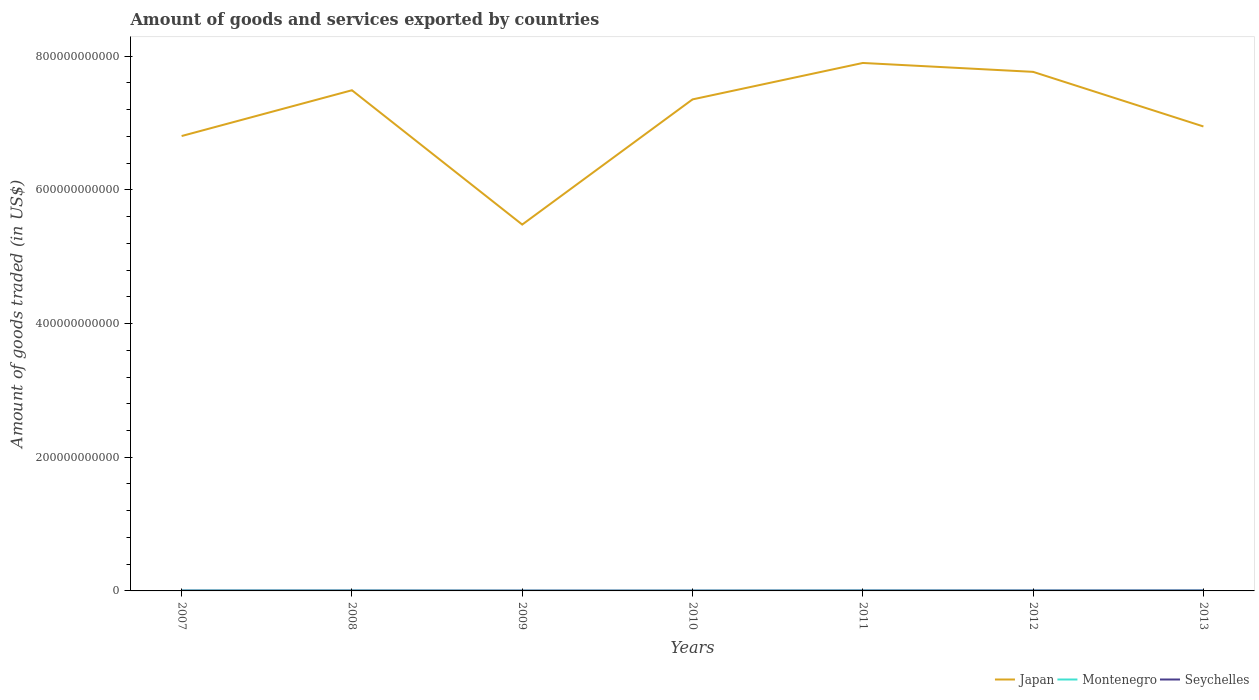Does the line corresponding to Montenegro intersect with the line corresponding to Seychelles?
Provide a succinct answer. Yes. Across all years, what is the maximum total amount of goods and services exported in Seychelles?
Keep it short and to the point. 3.98e+08. What is the total total amount of goods and services exported in Japan in the graph?
Ensure brevity in your answer.  -1.87e+11. What is the difference between the highest and the second highest total amount of goods and services exported in Seychelles?
Offer a terse response. 2.32e+08. How many years are there in the graph?
Keep it short and to the point. 7. What is the difference between two consecutive major ticks on the Y-axis?
Ensure brevity in your answer.  2.00e+11. Does the graph contain any zero values?
Ensure brevity in your answer.  No. How many legend labels are there?
Your response must be concise. 3. How are the legend labels stacked?
Provide a short and direct response. Horizontal. What is the title of the graph?
Your answer should be very brief. Amount of goods and services exported by countries. Does "Arab World" appear as one of the legend labels in the graph?
Offer a terse response. No. What is the label or title of the X-axis?
Make the answer very short. Years. What is the label or title of the Y-axis?
Give a very brief answer. Amount of goods traded (in US$). What is the Amount of goods traded (in US$) in Japan in 2007?
Offer a very short reply. 6.81e+11. What is the Amount of goods traded (in US$) in Montenegro in 2007?
Offer a very short reply. 6.48e+08. What is the Amount of goods traded (in US$) in Seychelles in 2007?
Your response must be concise. 3.98e+08. What is the Amount of goods traded (in US$) of Japan in 2008?
Offer a terse response. 7.49e+11. What is the Amount of goods traded (in US$) of Montenegro in 2008?
Your response must be concise. 6.23e+08. What is the Amount of goods traded (in US$) in Seychelles in 2008?
Make the answer very short. 4.38e+08. What is the Amount of goods traded (in US$) in Japan in 2009?
Your answer should be compact. 5.48e+11. What is the Amount of goods traded (in US$) of Montenegro in 2009?
Give a very brief answer. 3.83e+08. What is the Amount of goods traded (in US$) of Seychelles in 2009?
Offer a terse response. 4.32e+08. What is the Amount of goods traded (in US$) of Japan in 2010?
Ensure brevity in your answer.  7.35e+11. What is the Amount of goods traded (in US$) of Montenegro in 2010?
Your answer should be very brief. 4.49e+08. What is the Amount of goods traded (in US$) in Seychelles in 2010?
Offer a terse response. 4.00e+08. What is the Amount of goods traded (in US$) in Japan in 2011?
Offer a very short reply. 7.90e+11. What is the Amount of goods traded (in US$) in Montenegro in 2011?
Keep it short and to the point. 6.54e+08. What is the Amount of goods traded (in US$) of Seychelles in 2011?
Ensure brevity in your answer.  4.77e+08. What is the Amount of goods traded (in US$) of Japan in 2012?
Your answer should be very brief. 7.77e+11. What is the Amount of goods traded (in US$) in Montenegro in 2012?
Ensure brevity in your answer.  4.99e+08. What is the Amount of goods traded (in US$) in Seychelles in 2012?
Your answer should be compact. 5.59e+08. What is the Amount of goods traded (in US$) of Japan in 2013?
Offer a very short reply. 6.95e+11. What is the Amount of goods traded (in US$) of Montenegro in 2013?
Your response must be concise. 5.25e+08. What is the Amount of goods traded (in US$) in Seychelles in 2013?
Make the answer very short. 6.29e+08. Across all years, what is the maximum Amount of goods traded (in US$) in Japan?
Make the answer very short. 7.90e+11. Across all years, what is the maximum Amount of goods traded (in US$) in Montenegro?
Provide a succinct answer. 6.54e+08. Across all years, what is the maximum Amount of goods traded (in US$) of Seychelles?
Offer a very short reply. 6.29e+08. Across all years, what is the minimum Amount of goods traded (in US$) in Japan?
Offer a terse response. 5.48e+11. Across all years, what is the minimum Amount of goods traded (in US$) of Montenegro?
Provide a succinct answer. 3.83e+08. Across all years, what is the minimum Amount of goods traded (in US$) of Seychelles?
Give a very brief answer. 3.98e+08. What is the total Amount of goods traded (in US$) of Japan in the graph?
Your answer should be compact. 4.97e+12. What is the total Amount of goods traded (in US$) in Montenegro in the graph?
Your response must be concise. 3.78e+09. What is the total Amount of goods traded (in US$) of Seychelles in the graph?
Offer a terse response. 3.33e+09. What is the difference between the Amount of goods traded (in US$) in Japan in 2007 and that in 2008?
Provide a short and direct response. -6.85e+1. What is the difference between the Amount of goods traded (in US$) of Montenegro in 2007 and that in 2008?
Your answer should be compact. 2.54e+07. What is the difference between the Amount of goods traded (in US$) in Seychelles in 2007 and that in 2008?
Your answer should be very brief. -4.01e+07. What is the difference between the Amount of goods traded (in US$) in Japan in 2007 and that in 2009?
Your answer should be very brief. 1.32e+11. What is the difference between the Amount of goods traded (in US$) in Montenegro in 2007 and that in 2009?
Make the answer very short. 2.65e+08. What is the difference between the Amount of goods traded (in US$) in Seychelles in 2007 and that in 2009?
Make the answer very short. -3.42e+07. What is the difference between the Amount of goods traded (in US$) of Japan in 2007 and that in 2010?
Keep it short and to the point. -5.48e+1. What is the difference between the Amount of goods traded (in US$) in Montenegro in 2007 and that in 2010?
Make the answer very short. 1.99e+08. What is the difference between the Amount of goods traded (in US$) of Seychelles in 2007 and that in 2010?
Give a very brief answer. -2.68e+06. What is the difference between the Amount of goods traded (in US$) of Japan in 2007 and that in 2011?
Your answer should be very brief. -1.09e+11. What is the difference between the Amount of goods traded (in US$) of Montenegro in 2007 and that in 2011?
Provide a succinct answer. -5.49e+06. What is the difference between the Amount of goods traded (in US$) of Seychelles in 2007 and that in 2011?
Ensure brevity in your answer.  -7.93e+07. What is the difference between the Amount of goods traded (in US$) of Japan in 2007 and that in 2012?
Provide a succinct answer. -9.60e+1. What is the difference between the Amount of goods traded (in US$) in Montenegro in 2007 and that in 2012?
Offer a very short reply. 1.50e+08. What is the difference between the Amount of goods traded (in US$) of Seychelles in 2007 and that in 2012?
Your answer should be very brief. -1.62e+08. What is the difference between the Amount of goods traded (in US$) in Japan in 2007 and that in 2013?
Offer a terse response. -1.43e+1. What is the difference between the Amount of goods traded (in US$) in Montenegro in 2007 and that in 2013?
Give a very brief answer. 1.23e+08. What is the difference between the Amount of goods traded (in US$) of Seychelles in 2007 and that in 2013?
Give a very brief answer. -2.32e+08. What is the difference between the Amount of goods traded (in US$) in Japan in 2008 and that in 2009?
Offer a terse response. 2.01e+11. What is the difference between the Amount of goods traded (in US$) in Montenegro in 2008 and that in 2009?
Ensure brevity in your answer.  2.40e+08. What is the difference between the Amount of goods traded (in US$) in Seychelles in 2008 and that in 2009?
Make the answer very short. 5.81e+06. What is the difference between the Amount of goods traded (in US$) in Japan in 2008 and that in 2010?
Keep it short and to the point. 1.37e+1. What is the difference between the Amount of goods traded (in US$) in Montenegro in 2008 and that in 2010?
Offer a very short reply. 1.74e+08. What is the difference between the Amount of goods traded (in US$) in Seychelles in 2008 and that in 2010?
Provide a short and direct response. 3.74e+07. What is the difference between the Amount of goods traded (in US$) in Japan in 2008 and that in 2011?
Provide a succinct answer. -4.08e+1. What is the difference between the Amount of goods traded (in US$) of Montenegro in 2008 and that in 2011?
Your response must be concise. -3.09e+07. What is the difference between the Amount of goods traded (in US$) of Seychelles in 2008 and that in 2011?
Your answer should be compact. -3.93e+07. What is the difference between the Amount of goods traded (in US$) of Japan in 2008 and that in 2012?
Your answer should be compact. -2.75e+1. What is the difference between the Amount of goods traded (in US$) of Montenegro in 2008 and that in 2012?
Keep it short and to the point. 1.24e+08. What is the difference between the Amount of goods traded (in US$) in Seychelles in 2008 and that in 2012?
Your answer should be compact. -1.22e+08. What is the difference between the Amount of goods traded (in US$) in Japan in 2008 and that in 2013?
Make the answer very short. 5.42e+1. What is the difference between the Amount of goods traded (in US$) in Montenegro in 2008 and that in 2013?
Keep it short and to the point. 9.78e+07. What is the difference between the Amount of goods traded (in US$) of Seychelles in 2008 and that in 2013?
Your answer should be compact. -1.92e+08. What is the difference between the Amount of goods traded (in US$) of Japan in 2009 and that in 2010?
Your answer should be compact. -1.87e+11. What is the difference between the Amount of goods traded (in US$) in Montenegro in 2009 and that in 2010?
Give a very brief answer. -6.56e+07. What is the difference between the Amount of goods traded (in US$) in Seychelles in 2009 and that in 2010?
Your response must be concise. 3.16e+07. What is the difference between the Amount of goods traded (in US$) of Japan in 2009 and that in 2011?
Ensure brevity in your answer.  -2.42e+11. What is the difference between the Amount of goods traded (in US$) in Montenegro in 2009 and that in 2011?
Provide a short and direct response. -2.70e+08. What is the difference between the Amount of goods traded (in US$) in Seychelles in 2009 and that in 2011?
Offer a terse response. -4.51e+07. What is the difference between the Amount of goods traded (in US$) in Japan in 2009 and that in 2012?
Provide a short and direct response. -2.28e+11. What is the difference between the Amount of goods traded (in US$) of Montenegro in 2009 and that in 2012?
Offer a very short reply. -1.15e+08. What is the difference between the Amount of goods traded (in US$) of Seychelles in 2009 and that in 2012?
Provide a short and direct response. -1.27e+08. What is the difference between the Amount of goods traded (in US$) in Japan in 2009 and that in 2013?
Offer a very short reply. -1.47e+11. What is the difference between the Amount of goods traded (in US$) of Montenegro in 2009 and that in 2013?
Offer a very short reply. -1.42e+08. What is the difference between the Amount of goods traded (in US$) of Seychelles in 2009 and that in 2013?
Provide a short and direct response. -1.97e+08. What is the difference between the Amount of goods traded (in US$) in Japan in 2010 and that in 2011?
Offer a very short reply. -5.45e+1. What is the difference between the Amount of goods traded (in US$) in Montenegro in 2010 and that in 2011?
Offer a very short reply. -2.05e+08. What is the difference between the Amount of goods traded (in US$) in Seychelles in 2010 and that in 2011?
Provide a short and direct response. -7.67e+07. What is the difference between the Amount of goods traded (in US$) of Japan in 2010 and that in 2012?
Your answer should be very brief. -4.12e+1. What is the difference between the Amount of goods traded (in US$) of Montenegro in 2010 and that in 2012?
Provide a short and direct response. -4.95e+07. What is the difference between the Amount of goods traded (in US$) of Seychelles in 2010 and that in 2012?
Provide a succinct answer. -1.59e+08. What is the difference between the Amount of goods traded (in US$) in Japan in 2010 and that in 2013?
Give a very brief answer. 4.05e+1. What is the difference between the Amount of goods traded (in US$) of Montenegro in 2010 and that in 2013?
Offer a terse response. -7.62e+07. What is the difference between the Amount of goods traded (in US$) in Seychelles in 2010 and that in 2013?
Your response must be concise. -2.29e+08. What is the difference between the Amount of goods traded (in US$) in Japan in 2011 and that in 2012?
Make the answer very short. 1.33e+1. What is the difference between the Amount of goods traded (in US$) of Montenegro in 2011 and that in 2012?
Your answer should be very brief. 1.55e+08. What is the difference between the Amount of goods traded (in US$) of Seychelles in 2011 and that in 2012?
Ensure brevity in your answer.  -8.22e+07. What is the difference between the Amount of goods traded (in US$) of Japan in 2011 and that in 2013?
Provide a succinct answer. 9.50e+1. What is the difference between the Amount of goods traded (in US$) of Montenegro in 2011 and that in 2013?
Provide a short and direct response. 1.29e+08. What is the difference between the Amount of goods traded (in US$) in Seychelles in 2011 and that in 2013?
Offer a terse response. -1.52e+08. What is the difference between the Amount of goods traded (in US$) in Japan in 2012 and that in 2013?
Provide a succinct answer. 8.17e+1. What is the difference between the Amount of goods traded (in US$) of Montenegro in 2012 and that in 2013?
Give a very brief answer. -2.67e+07. What is the difference between the Amount of goods traded (in US$) in Seychelles in 2012 and that in 2013?
Provide a short and direct response. -7.01e+07. What is the difference between the Amount of goods traded (in US$) in Japan in 2007 and the Amount of goods traded (in US$) in Montenegro in 2008?
Provide a short and direct response. 6.80e+11. What is the difference between the Amount of goods traded (in US$) in Japan in 2007 and the Amount of goods traded (in US$) in Seychelles in 2008?
Your response must be concise. 6.80e+11. What is the difference between the Amount of goods traded (in US$) in Montenegro in 2007 and the Amount of goods traded (in US$) in Seychelles in 2008?
Make the answer very short. 2.11e+08. What is the difference between the Amount of goods traded (in US$) in Japan in 2007 and the Amount of goods traded (in US$) in Montenegro in 2009?
Ensure brevity in your answer.  6.80e+11. What is the difference between the Amount of goods traded (in US$) in Japan in 2007 and the Amount of goods traded (in US$) in Seychelles in 2009?
Your answer should be very brief. 6.80e+11. What is the difference between the Amount of goods traded (in US$) of Montenegro in 2007 and the Amount of goods traded (in US$) of Seychelles in 2009?
Your answer should be compact. 2.17e+08. What is the difference between the Amount of goods traded (in US$) in Japan in 2007 and the Amount of goods traded (in US$) in Montenegro in 2010?
Keep it short and to the point. 6.80e+11. What is the difference between the Amount of goods traded (in US$) of Japan in 2007 and the Amount of goods traded (in US$) of Seychelles in 2010?
Your response must be concise. 6.80e+11. What is the difference between the Amount of goods traded (in US$) of Montenegro in 2007 and the Amount of goods traded (in US$) of Seychelles in 2010?
Your answer should be very brief. 2.48e+08. What is the difference between the Amount of goods traded (in US$) in Japan in 2007 and the Amount of goods traded (in US$) in Montenegro in 2011?
Provide a short and direct response. 6.80e+11. What is the difference between the Amount of goods traded (in US$) of Japan in 2007 and the Amount of goods traded (in US$) of Seychelles in 2011?
Your answer should be very brief. 6.80e+11. What is the difference between the Amount of goods traded (in US$) in Montenegro in 2007 and the Amount of goods traded (in US$) in Seychelles in 2011?
Your response must be concise. 1.72e+08. What is the difference between the Amount of goods traded (in US$) in Japan in 2007 and the Amount of goods traded (in US$) in Montenegro in 2012?
Give a very brief answer. 6.80e+11. What is the difference between the Amount of goods traded (in US$) of Japan in 2007 and the Amount of goods traded (in US$) of Seychelles in 2012?
Ensure brevity in your answer.  6.80e+11. What is the difference between the Amount of goods traded (in US$) in Montenegro in 2007 and the Amount of goods traded (in US$) in Seychelles in 2012?
Provide a short and direct response. 8.93e+07. What is the difference between the Amount of goods traded (in US$) in Japan in 2007 and the Amount of goods traded (in US$) in Montenegro in 2013?
Provide a succinct answer. 6.80e+11. What is the difference between the Amount of goods traded (in US$) in Japan in 2007 and the Amount of goods traded (in US$) in Seychelles in 2013?
Your answer should be compact. 6.80e+11. What is the difference between the Amount of goods traded (in US$) in Montenegro in 2007 and the Amount of goods traded (in US$) in Seychelles in 2013?
Your response must be concise. 1.92e+07. What is the difference between the Amount of goods traded (in US$) in Japan in 2008 and the Amount of goods traded (in US$) in Montenegro in 2009?
Make the answer very short. 7.49e+11. What is the difference between the Amount of goods traded (in US$) in Japan in 2008 and the Amount of goods traded (in US$) in Seychelles in 2009?
Provide a short and direct response. 7.49e+11. What is the difference between the Amount of goods traded (in US$) of Montenegro in 2008 and the Amount of goods traded (in US$) of Seychelles in 2009?
Provide a succinct answer. 1.91e+08. What is the difference between the Amount of goods traded (in US$) in Japan in 2008 and the Amount of goods traded (in US$) in Montenegro in 2010?
Provide a short and direct response. 7.49e+11. What is the difference between the Amount of goods traded (in US$) of Japan in 2008 and the Amount of goods traded (in US$) of Seychelles in 2010?
Offer a very short reply. 7.49e+11. What is the difference between the Amount of goods traded (in US$) of Montenegro in 2008 and the Amount of goods traded (in US$) of Seychelles in 2010?
Your response must be concise. 2.23e+08. What is the difference between the Amount of goods traded (in US$) of Japan in 2008 and the Amount of goods traded (in US$) of Montenegro in 2011?
Keep it short and to the point. 7.48e+11. What is the difference between the Amount of goods traded (in US$) of Japan in 2008 and the Amount of goods traded (in US$) of Seychelles in 2011?
Your answer should be compact. 7.49e+11. What is the difference between the Amount of goods traded (in US$) of Montenegro in 2008 and the Amount of goods traded (in US$) of Seychelles in 2011?
Your response must be concise. 1.46e+08. What is the difference between the Amount of goods traded (in US$) of Japan in 2008 and the Amount of goods traded (in US$) of Montenegro in 2012?
Offer a terse response. 7.49e+11. What is the difference between the Amount of goods traded (in US$) of Japan in 2008 and the Amount of goods traded (in US$) of Seychelles in 2012?
Provide a succinct answer. 7.49e+11. What is the difference between the Amount of goods traded (in US$) of Montenegro in 2008 and the Amount of goods traded (in US$) of Seychelles in 2012?
Provide a short and direct response. 6.39e+07. What is the difference between the Amount of goods traded (in US$) of Japan in 2008 and the Amount of goods traded (in US$) of Montenegro in 2013?
Offer a terse response. 7.49e+11. What is the difference between the Amount of goods traded (in US$) in Japan in 2008 and the Amount of goods traded (in US$) in Seychelles in 2013?
Your answer should be very brief. 7.48e+11. What is the difference between the Amount of goods traded (in US$) of Montenegro in 2008 and the Amount of goods traded (in US$) of Seychelles in 2013?
Give a very brief answer. -6.18e+06. What is the difference between the Amount of goods traded (in US$) of Japan in 2009 and the Amount of goods traded (in US$) of Montenegro in 2010?
Your answer should be compact. 5.48e+11. What is the difference between the Amount of goods traded (in US$) in Japan in 2009 and the Amount of goods traded (in US$) in Seychelles in 2010?
Provide a short and direct response. 5.48e+11. What is the difference between the Amount of goods traded (in US$) of Montenegro in 2009 and the Amount of goods traded (in US$) of Seychelles in 2010?
Your response must be concise. -1.68e+07. What is the difference between the Amount of goods traded (in US$) in Japan in 2009 and the Amount of goods traded (in US$) in Montenegro in 2011?
Your answer should be very brief. 5.47e+11. What is the difference between the Amount of goods traded (in US$) of Japan in 2009 and the Amount of goods traded (in US$) of Seychelles in 2011?
Your answer should be very brief. 5.48e+11. What is the difference between the Amount of goods traded (in US$) of Montenegro in 2009 and the Amount of goods traded (in US$) of Seychelles in 2011?
Provide a short and direct response. -9.34e+07. What is the difference between the Amount of goods traded (in US$) in Japan in 2009 and the Amount of goods traded (in US$) in Montenegro in 2012?
Your response must be concise. 5.48e+11. What is the difference between the Amount of goods traded (in US$) in Japan in 2009 and the Amount of goods traded (in US$) in Seychelles in 2012?
Your answer should be very brief. 5.48e+11. What is the difference between the Amount of goods traded (in US$) of Montenegro in 2009 and the Amount of goods traded (in US$) of Seychelles in 2012?
Your answer should be very brief. -1.76e+08. What is the difference between the Amount of goods traded (in US$) in Japan in 2009 and the Amount of goods traded (in US$) in Montenegro in 2013?
Give a very brief answer. 5.48e+11. What is the difference between the Amount of goods traded (in US$) of Japan in 2009 and the Amount of goods traded (in US$) of Seychelles in 2013?
Provide a short and direct response. 5.48e+11. What is the difference between the Amount of goods traded (in US$) in Montenegro in 2009 and the Amount of goods traded (in US$) in Seychelles in 2013?
Give a very brief answer. -2.46e+08. What is the difference between the Amount of goods traded (in US$) in Japan in 2010 and the Amount of goods traded (in US$) in Montenegro in 2011?
Ensure brevity in your answer.  7.35e+11. What is the difference between the Amount of goods traded (in US$) in Japan in 2010 and the Amount of goods traded (in US$) in Seychelles in 2011?
Ensure brevity in your answer.  7.35e+11. What is the difference between the Amount of goods traded (in US$) of Montenegro in 2010 and the Amount of goods traded (in US$) of Seychelles in 2011?
Offer a very short reply. -2.78e+07. What is the difference between the Amount of goods traded (in US$) in Japan in 2010 and the Amount of goods traded (in US$) in Montenegro in 2012?
Offer a terse response. 7.35e+11. What is the difference between the Amount of goods traded (in US$) in Japan in 2010 and the Amount of goods traded (in US$) in Seychelles in 2012?
Provide a succinct answer. 7.35e+11. What is the difference between the Amount of goods traded (in US$) in Montenegro in 2010 and the Amount of goods traded (in US$) in Seychelles in 2012?
Ensure brevity in your answer.  -1.10e+08. What is the difference between the Amount of goods traded (in US$) in Japan in 2010 and the Amount of goods traded (in US$) in Montenegro in 2013?
Ensure brevity in your answer.  7.35e+11. What is the difference between the Amount of goods traded (in US$) of Japan in 2010 and the Amount of goods traded (in US$) of Seychelles in 2013?
Your answer should be very brief. 7.35e+11. What is the difference between the Amount of goods traded (in US$) of Montenegro in 2010 and the Amount of goods traded (in US$) of Seychelles in 2013?
Your response must be concise. -1.80e+08. What is the difference between the Amount of goods traded (in US$) in Japan in 2011 and the Amount of goods traded (in US$) in Montenegro in 2012?
Offer a very short reply. 7.89e+11. What is the difference between the Amount of goods traded (in US$) of Japan in 2011 and the Amount of goods traded (in US$) of Seychelles in 2012?
Provide a short and direct response. 7.89e+11. What is the difference between the Amount of goods traded (in US$) in Montenegro in 2011 and the Amount of goods traded (in US$) in Seychelles in 2012?
Ensure brevity in your answer.  9.48e+07. What is the difference between the Amount of goods traded (in US$) of Japan in 2011 and the Amount of goods traded (in US$) of Montenegro in 2013?
Give a very brief answer. 7.89e+11. What is the difference between the Amount of goods traded (in US$) of Japan in 2011 and the Amount of goods traded (in US$) of Seychelles in 2013?
Provide a succinct answer. 7.89e+11. What is the difference between the Amount of goods traded (in US$) of Montenegro in 2011 and the Amount of goods traded (in US$) of Seychelles in 2013?
Your answer should be very brief. 2.47e+07. What is the difference between the Amount of goods traded (in US$) of Japan in 2012 and the Amount of goods traded (in US$) of Montenegro in 2013?
Your answer should be compact. 7.76e+11. What is the difference between the Amount of goods traded (in US$) in Japan in 2012 and the Amount of goods traded (in US$) in Seychelles in 2013?
Give a very brief answer. 7.76e+11. What is the difference between the Amount of goods traded (in US$) in Montenegro in 2012 and the Amount of goods traded (in US$) in Seychelles in 2013?
Your response must be concise. -1.31e+08. What is the average Amount of goods traded (in US$) in Japan per year?
Keep it short and to the point. 7.11e+11. What is the average Amount of goods traded (in US$) in Montenegro per year?
Give a very brief answer. 5.40e+08. What is the average Amount of goods traded (in US$) of Seychelles per year?
Your answer should be very brief. 4.76e+08. In the year 2007, what is the difference between the Amount of goods traded (in US$) of Japan and Amount of goods traded (in US$) of Montenegro?
Your answer should be very brief. 6.80e+11. In the year 2007, what is the difference between the Amount of goods traded (in US$) of Japan and Amount of goods traded (in US$) of Seychelles?
Your answer should be very brief. 6.80e+11. In the year 2007, what is the difference between the Amount of goods traded (in US$) of Montenegro and Amount of goods traded (in US$) of Seychelles?
Keep it short and to the point. 2.51e+08. In the year 2008, what is the difference between the Amount of goods traded (in US$) in Japan and Amount of goods traded (in US$) in Montenegro?
Your response must be concise. 7.48e+11. In the year 2008, what is the difference between the Amount of goods traded (in US$) of Japan and Amount of goods traded (in US$) of Seychelles?
Offer a terse response. 7.49e+11. In the year 2008, what is the difference between the Amount of goods traded (in US$) in Montenegro and Amount of goods traded (in US$) in Seychelles?
Your answer should be compact. 1.85e+08. In the year 2009, what is the difference between the Amount of goods traded (in US$) of Japan and Amount of goods traded (in US$) of Montenegro?
Your answer should be very brief. 5.48e+11. In the year 2009, what is the difference between the Amount of goods traded (in US$) of Japan and Amount of goods traded (in US$) of Seychelles?
Offer a very short reply. 5.48e+11. In the year 2009, what is the difference between the Amount of goods traded (in US$) in Montenegro and Amount of goods traded (in US$) in Seychelles?
Give a very brief answer. -4.83e+07. In the year 2010, what is the difference between the Amount of goods traded (in US$) of Japan and Amount of goods traded (in US$) of Montenegro?
Ensure brevity in your answer.  7.35e+11. In the year 2010, what is the difference between the Amount of goods traded (in US$) in Japan and Amount of goods traded (in US$) in Seychelles?
Give a very brief answer. 7.35e+11. In the year 2010, what is the difference between the Amount of goods traded (in US$) of Montenegro and Amount of goods traded (in US$) of Seychelles?
Offer a very short reply. 4.88e+07. In the year 2011, what is the difference between the Amount of goods traded (in US$) of Japan and Amount of goods traded (in US$) of Montenegro?
Provide a succinct answer. 7.89e+11. In the year 2011, what is the difference between the Amount of goods traded (in US$) of Japan and Amount of goods traded (in US$) of Seychelles?
Offer a very short reply. 7.89e+11. In the year 2011, what is the difference between the Amount of goods traded (in US$) in Montenegro and Amount of goods traded (in US$) in Seychelles?
Your answer should be very brief. 1.77e+08. In the year 2012, what is the difference between the Amount of goods traded (in US$) in Japan and Amount of goods traded (in US$) in Montenegro?
Offer a terse response. 7.76e+11. In the year 2012, what is the difference between the Amount of goods traded (in US$) of Japan and Amount of goods traded (in US$) of Seychelles?
Your response must be concise. 7.76e+11. In the year 2012, what is the difference between the Amount of goods traded (in US$) in Montenegro and Amount of goods traded (in US$) in Seychelles?
Your answer should be compact. -6.06e+07. In the year 2013, what is the difference between the Amount of goods traded (in US$) in Japan and Amount of goods traded (in US$) in Montenegro?
Offer a terse response. 6.94e+11. In the year 2013, what is the difference between the Amount of goods traded (in US$) of Japan and Amount of goods traded (in US$) of Seychelles?
Give a very brief answer. 6.94e+11. In the year 2013, what is the difference between the Amount of goods traded (in US$) in Montenegro and Amount of goods traded (in US$) in Seychelles?
Offer a terse response. -1.04e+08. What is the ratio of the Amount of goods traded (in US$) in Japan in 2007 to that in 2008?
Offer a terse response. 0.91. What is the ratio of the Amount of goods traded (in US$) of Montenegro in 2007 to that in 2008?
Give a very brief answer. 1.04. What is the ratio of the Amount of goods traded (in US$) of Seychelles in 2007 to that in 2008?
Offer a terse response. 0.91. What is the ratio of the Amount of goods traded (in US$) of Japan in 2007 to that in 2009?
Provide a succinct answer. 1.24. What is the ratio of the Amount of goods traded (in US$) of Montenegro in 2007 to that in 2009?
Your answer should be very brief. 1.69. What is the ratio of the Amount of goods traded (in US$) in Seychelles in 2007 to that in 2009?
Ensure brevity in your answer.  0.92. What is the ratio of the Amount of goods traded (in US$) of Japan in 2007 to that in 2010?
Your answer should be very brief. 0.93. What is the ratio of the Amount of goods traded (in US$) in Montenegro in 2007 to that in 2010?
Give a very brief answer. 1.44. What is the ratio of the Amount of goods traded (in US$) in Seychelles in 2007 to that in 2010?
Offer a very short reply. 0.99. What is the ratio of the Amount of goods traded (in US$) of Japan in 2007 to that in 2011?
Offer a terse response. 0.86. What is the ratio of the Amount of goods traded (in US$) of Montenegro in 2007 to that in 2011?
Keep it short and to the point. 0.99. What is the ratio of the Amount of goods traded (in US$) of Seychelles in 2007 to that in 2011?
Give a very brief answer. 0.83. What is the ratio of the Amount of goods traded (in US$) of Japan in 2007 to that in 2012?
Your answer should be compact. 0.88. What is the ratio of the Amount of goods traded (in US$) in Montenegro in 2007 to that in 2012?
Give a very brief answer. 1.3. What is the ratio of the Amount of goods traded (in US$) of Seychelles in 2007 to that in 2012?
Offer a terse response. 0.71. What is the ratio of the Amount of goods traded (in US$) of Japan in 2007 to that in 2013?
Your answer should be very brief. 0.98. What is the ratio of the Amount of goods traded (in US$) of Montenegro in 2007 to that in 2013?
Your answer should be very brief. 1.23. What is the ratio of the Amount of goods traded (in US$) in Seychelles in 2007 to that in 2013?
Your answer should be compact. 0.63. What is the ratio of the Amount of goods traded (in US$) of Japan in 2008 to that in 2009?
Make the answer very short. 1.37. What is the ratio of the Amount of goods traded (in US$) of Montenegro in 2008 to that in 2009?
Make the answer very short. 1.62. What is the ratio of the Amount of goods traded (in US$) in Seychelles in 2008 to that in 2009?
Offer a terse response. 1.01. What is the ratio of the Amount of goods traded (in US$) of Japan in 2008 to that in 2010?
Your answer should be compact. 1.02. What is the ratio of the Amount of goods traded (in US$) in Montenegro in 2008 to that in 2010?
Give a very brief answer. 1.39. What is the ratio of the Amount of goods traded (in US$) of Seychelles in 2008 to that in 2010?
Keep it short and to the point. 1.09. What is the ratio of the Amount of goods traded (in US$) of Japan in 2008 to that in 2011?
Offer a very short reply. 0.95. What is the ratio of the Amount of goods traded (in US$) of Montenegro in 2008 to that in 2011?
Ensure brevity in your answer.  0.95. What is the ratio of the Amount of goods traded (in US$) in Seychelles in 2008 to that in 2011?
Your answer should be very brief. 0.92. What is the ratio of the Amount of goods traded (in US$) of Japan in 2008 to that in 2012?
Keep it short and to the point. 0.96. What is the ratio of the Amount of goods traded (in US$) in Montenegro in 2008 to that in 2012?
Offer a very short reply. 1.25. What is the ratio of the Amount of goods traded (in US$) of Seychelles in 2008 to that in 2012?
Give a very brief answer. 0.78. What is the ratio of the Amount of goods traded (in US$) of Japan in 2008 to that in 2013?
Your response must be concise. 1.08. What is the ratio of the Amount of goods traded (in US$) in Montenegro in 2008 to that in 2013?
Provide a succinct answer. 1.19. What is the ratio of the Amount of goods traded (in US$) of Seychelles in 2008 to that in 2013?
Offer a very short reply. 0.7. What is the ratio of the Amount of goods traded (in US$) in Japan in 2009 to that in 2010?
Give a very brief answer. 0.75. What is the ratio of the Amount of goods traded (in US$) in Montenegro in 2009 to that in 2010?
Provide a succinct answer. 0.85. What is the ratio of the Amount of goods traded (in US$) of Seychelles in 2009 to that in 2010?
Offer a terse response. 1.08. What is the ratio of the Amount of goods traded (in US$) of Japan in 2009 to that in 2011?
Offer a terse response. 0.69. What is the ratio of the Amount of goods traded (in US$) in Montenegro in 2009 to that in 2011?
Give a very brief answer. 0.59. What is the ratio of the Amount of goods traded (in US$) of Seychelles in 2009 to that in 2011?
Your answer should be very brief. 0.91. What is the ratio of the Amount of goods traded (in US$) in Japan in 2009 to that in 2012?
Your answer should be very brief. 0.71. What is the ratio of the Amount of goods traded (in US$) in Montenegro in 2009 to that in 2012?
Give a very brief answer. 0.77. What is the ratio of the Amount of goods traded (in US$) of Seychelles in 2009 to that in 2012?
Ensure brevity in your answer.  0.77. What is the ratio of the Amount of goods traded (in US$) of Japan in 2009 to that in 2013?
Offer a terse response. 0.79. What is the ratio of the Amount of goods traded (in US$) in Montenegro in 2009 to that in 2013?
Ensure brevity in your answer.  0.73. What is the ratio of the Amount of goods traded (in US$) in Seychelles in 2009 to that in 2013?
Offer a very short reply. 0.69. What is the ratio of the Amount of goods traded (in US$) in Montenegro in 2010 to that in 2011?
Your answer should be very brief. 0.69. What is the ratio of the Amount of goods traded (in US$) of Seychelles in 2010 to that in 2011?
Make the answer very short. 0.84. What is the ratio of the Amount of goods traded (in US$) in Japan in 2010 to that in 2012?
Keep it short and to the point. 0.95. What is the ratio of the Amount of goods traded (in US$) of Montenegro in 2010 to that in 2012?
Your answer should be very brief. 0.9. What is the ratio of the Amount of goods traded (in US$) of Seychelles in 2010 to that in 2012?
Your answer should be compact. 0.72. What is the ratio of the Amount of goods traded (in US$) of Japan in 2010 to that in 2013?
Provide a succinct answer. 1.06. What is the ratio of the Amount of goods traded (in US$) in Montenegro in 2010 to that in 2013?
Your answer should be compact. 0.85. What is the ratio of the Amount of goods traded (in US$) of Seychelles in 2010 to that in 2013?
Provide a succinct answer. 0.64. What is the ratio of the Amount of goods traded (in US$) in Japan in 2011 to that in 2012?
Ensure brevity in your answer.  1.02. What is the ratio of the Amount of goods traded (in US$) in Montenegro in 2011 to that in 2012?
Offer a terse response. 1.31. What is the ratio of the Amount of goods traded (in US$) of Seychelles in 2011 to that in 2012?
Offer a very short reply. 0.85. What is the ratio of the Amount of goods traded (in US$) of Japan in 2011 to that in 2013?
Keep it short and to the point. 1.14. What is the ratio of the Amount of goods traded (in US$) of Montenegro in 2011 to that in 2013?
Provide a succinct answer. 1.24. What is the ratio of the Amount of goods traded (in US$) of Seychelles in 2011 to that in 2013?
Provide a short and direct response. 0.76. What is the ratio of the Amount of goods traded (in US$) in Japan in 2012 to that in 2013?
Keep it short and to the point. 1.12. What is the ratio of the Amount of goods traded (in US$) of Montenegro in 2012 to that in 2013?
Keep it short and to the point. 0.95. What is the ratio of the Amount of goods traded (in US$) in Seychelles in 2012 to that in 2013?
Your answer should be compact. 0.89. What is the difference between the highest and the second highest Amount of goods traded (in US$) in Japan?
Keep it short and to the point. 1.33e+1. What is the difference between the highest and the second highest Amount of goods traded (in US$) in Montenegro?
Provide a succinct answer. 5.49e+06. What is the difference between the highest and the second highest Amount of goods traded (in US$) in Seychelles?
Give a very brief answer. 7.01e+07. What is the difference between the highest and the lowest Amount of goods traded (in US$) in Japan?
Your answer should be compact. 2.42e+11. What is the difference between the highest and the lowest Amount of goods traded (in US$) of Montenegro?
Your answer should be compact. 2.70e+08. What is the difference between the highest and the lowest Amount of goods traded (in US$) of Seychelles?
Your response must be concise. 2.32e+08. 